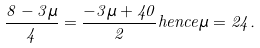<formula> <loc_0><loc_0><loc_500><loc_500>\frac { 8 - 3 \mu } { 4 } = \frac { - 3 \mu + 4 0 } { 2 } h e n c e \mu = 2 4 .</formula> 